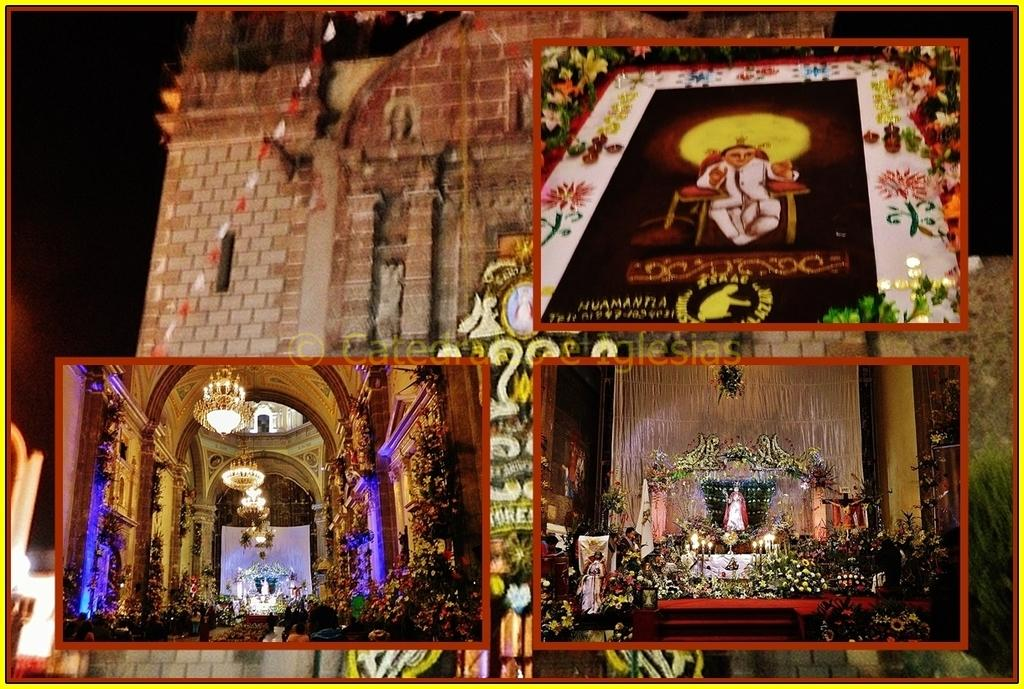What type of structures can be seen in the image? There are buildings in the image. What type of lighting fixtures are present in the image? There are chandeliers and candles in the image. What type of illumination is visible in the image? There are lights in the image. What type of decorative items can be seen in the image? There are flower bouquets in the image. What other objects can be seen in the image? There are other objects in the image, but their specific details are not mentioned in the provided facts. What type of calculator is being used in the image? There is no calculator present in the image. --- Facts: 1. There is a person in the image. 12. The person is wearing a hat. 13. The person is holding a book. 14. The person is standing on a wooden platform. 15. The background of the image is a forest. Absurd Topics: spaceship, alien, space suit Conversation: Who or what is present in the image? There is a person in the image. What is the person wearing on their head? The person is wearing a hat. What is the person holding in their hands? The person is holding a book. What is the person standing on? The person is standing on a wooden platform. What can be seen in the background of the image? The background of the image is a forest. Reasoning: Let's think step by step in order to produce the conversation. We start by identifying the main subject in the image, which is the person. Then, we describe specific features of the person, such as the hat and the book they are holding. Next, we observe the person's location, noting that they are standing on a wooden platform. Finally, we describe the background of the image, which is a forest. Absurd Question/Answer: What type of spaceship can be seen flying in the image? There is no spaceship present in the image. --- Facts: 1. There is a person in the image. 12. The person is wearing a red shirt. 13. The person is sitting on a chair. 14. The person is holding a cup of coffee. 15. The background of the image is a coffee shop. Absurd Topics: surfboard, beach, sandcastle Conversation: Who or what is present in the image? There is a person in the image. What is the person wearing on their upper body? The person is wearing a red shirt. What is the person sitting on? The person is sitting on a chair. What is the person holding in their hands? The person is holding a cup of coffee. What can be seen in the background of the image? The background of the image is a coffee shop 